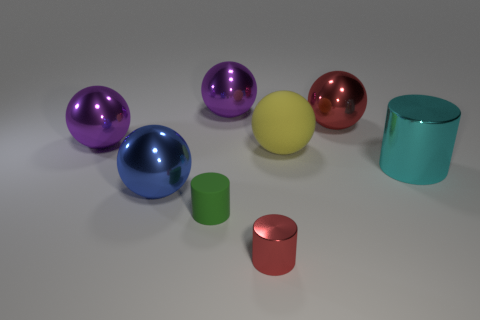Add 2 big cylinders. How many objects exist? 10 Subtract all cylinders. How many objects are left? 5 Add 5 big matte things. How many big matte things are left? 6 Add 8 small green things. How many small green things exist? 9 Subtract 0 gray blocks. How many objects are left? 8 Subtract all tiny rubber objects. Subtract all purple shiny objects. How many objects are left? 5 